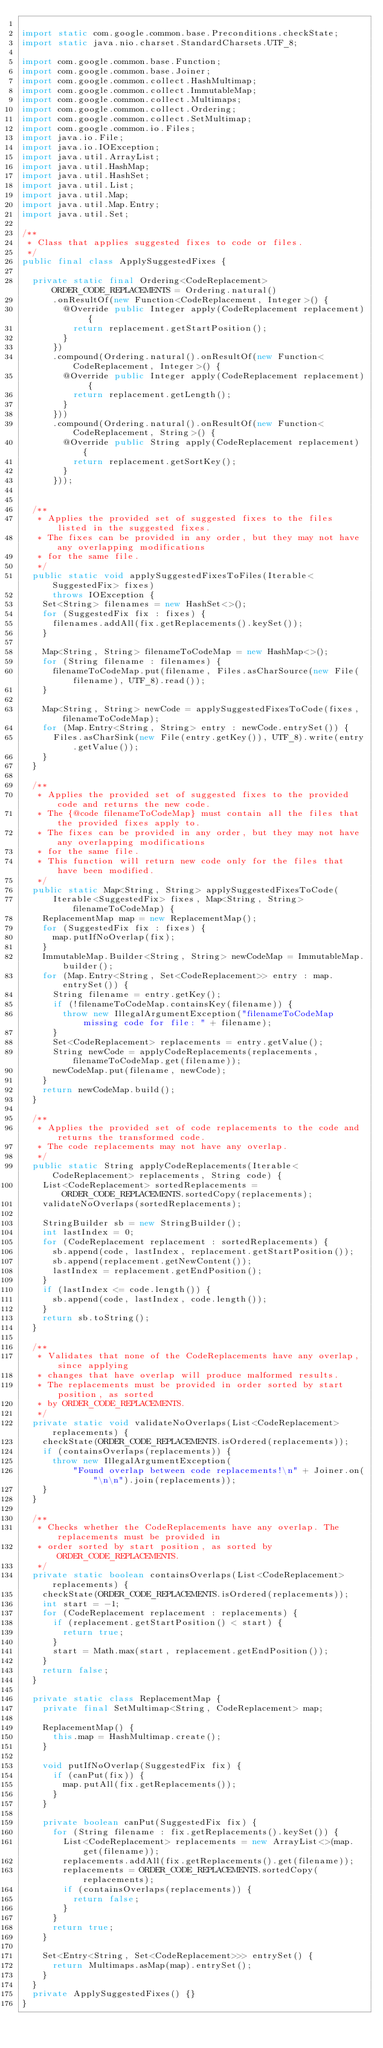<code> <loc_0><loc_0><loc_500><loc_500><_Java_>
import static com.google.common.base.Preconditions.checkState;
import static java.nio.charset.StandardCharsets.UTF_8;

import com.google.common.base.Function;
import com.google.common.base.Joiner;
import com.google.common.collect.HashMultimap;
import com.google.common.collect.ImmutableMap;
import com.google.common.collect.Multimaps;
import com.google.common.collect.Ordering;
import com.google.common.collect.SetMultimap;
import com.google.common.io.Files;
import java.io.File;
import java.io.IOException;
import java.util.ArrayList;
import java.util.HashMap;
import java.util.HashSet;
import java.util.List;
import java.util.Map;
import java.util.Map.Entry;
import java.util.Set;

/**
 * Class that applies suggested fixes to code or files.
 */
public final class ApplySuggestedFixes {

  private static final Ordering<CodeReplacement> ORDER_CODE_REPLACEMENTS = Ordering.natural()
      .onResultOf(new Function<CodeReplacement, Integer>() {
        @Override public Integer apply(CodeReplacement replacement) {
          return replacement.getStartPosition();
        }
      })
      .compound(Ordering.natural().onResultOf(new Function<CodeReplacement, Integer>() {
        @Override public Integer apply(CodeReplacement replacement) {
          return replacement.getLength();
        }
      }))
      .compound(Ordering.natural().onResultOf(new Function<CodeReplacement, String>() {
        @Override public String apply(CodeReplacement replacement) {
          return replacement.getSortKey();
        }
      }));


  /**
   * Applies the provided set of suggested fixes to the files listed in the suggested fixes.
   * The fixes can be provided in any order, but they may not have any overlapping modifications
   * for the same file.
   */
  public static void applySuggestedFixesToFiles(Iterable<SuggestedFix> fixes)
      throws IOException {
    Set<String> filenames = new HashSet<>();
    for (SuggestedFix fix : fixes) {
      filenames.addAll(fix.getReplacements().keySet());
    }

    Map<String, String> filenameToCodeMap = new HashMap<>();
    for (String filename : filenames) {
      filenameToCodeMap.put(filename, Files.asCharSource(new File(filename), UTF_8).read());
    }

    Map<String, String> newCode = applySuggestedFixesToCode(fixes, filenameToCodeMap);
    for (Map.Entry<String, String> entry : newCode.entrySet()) {
      Files.asCharSink(new File(entry.getKey()), UTF_8).write(entry.getValue());
    }
  }

  /**
   * Applies the provided set of suggested fixes to the provided code and returns the new code.
   * The {@code filenameToCodeMap} must contain all the files that the provided fixes apply to.
   * The fixes can be provided in any order, but they may not have any overlapping modifications
   * for the same file.
   * This function will return new code only for the files that have been modified.
   */
  public static Map<String, String> applySuggestedFixesToCode(
      Iterable<SuggestedFix> fixes, Map<String, String> filenameToCodeMap) {
    ReplacementMap map = new ReplacementMap();
    for (SuggestedFix fix : fixes) {
      map.putIfNoOverlap(fix);
    }
    ImmutableMap.Builder<String, String> newCodeMap = ImmutableMap.builder();
    for (Map.Entry<String, Set<CodeReplacement>> entry : map.entrySet()) {
      String filename = entry.getKey();
      if (!filenameToCodeMap.containsKey(filename)) {
        throw new IllegalArgumentException("filenameToCodeMap missing code for file: " + filename);
      }
      Set<CodeReplacement> replacements = entry.getValue();
      String newCode = applyCodeReplacements(replacements, filenameToCodeMap.get(filename));
      newCodeMap.put(filename, newCode);
    }
    return newCodeMap.build();
  }

  /**
   * Applies the provided set of code replacements to the code and returns the transformed code.
   * The code replacements may not have any overlap.
   */
  public static String applyCodeReplacements(Iterable<CodeReplacement> replacements, String code) {
    List<CodeReplacement> sortedReplacements = ORDER_CODE_REPLACEMENTS.sortedCopy(replacements);
    validateNoOverlaps(sortedReplacements);

    StringBuilder sb = new StringBuilder();
    int lastIndex = 0;
    for (CodeReplacement replacement : sortedReplacements) {
      sb.append(code, lastIndex, replacement.getStartPosition());
      sb.append(replacement.getNewContent());
      lastIndex = replacement.getEndPosition();
    }
    if (lastIndex <= code.length()) {
      sb.append(code, lastIndex, code.length());
    }
    return sb.toString();
  }

  /**
   * Validates that none of the CodeReplacements have any overlap, since applying
   * changes that have overlap will produce malformed results.
   * The replacements must be provided in order sorted by start position, as sorted
   * by ORDER_CODE_REPLACEMENTS.
   */
  private static void validateNoOverlaps(List<CodeReplacement> replacements) {
    checkState(ORDER_CODE_REPLACEMENTS.isOrdered(replacements));
    if (containsOverlaps(replacements)) {
      throw new IllegalArgumentException(
          "Found overlap between code replacements!\n" + Joiner.on("\n\n").join(replacements));
    }
  }

  /**
   * Checks whether the CodeReplacements have any overlap. The replacements must be provided in
   * order sorted by start position, as sorted by ORDER_CODE_REPLACEMENTS.
   */
  private static boolean containsOverlaps(List<CodeReplacement> replacements) {
    checkState(ORDER_CODE_REPLACEMENTS.isOrdered(replacements));
    int start = -1;
    for (CodeReplacement replacement : replacements) {
      if (replacement.getStartPosition() < start) {
        return true;
      }
      start = Math.max(start, replacement.getEndPosition());
    }
    return false;
  }

  private static class ReplacementMap {
    private final SetMultimap<String, CodeReplacement> map;

    ReplacementMap() {
      this.map = HashMultimap.create();
    }

    void putIfNoOverlap(SuggestedFix fix) {
      if (canPut(fix)) {
        map.putAll(fix.getReplacements());
      }
    }

    private boolean canPut(SuggestedFix fix) {
      for (String filename : fix.getReplacements().keySet()) {
        List<CodeReplacement> replacements = new ArrayList<>(map.get(filename));
        replacements.addAll(fix.getReplacements().get(filename));
        replacements = ORDER_CODE_REPLACEMENTS.sortedCopy(replacements);
        if (containsOverlaps(replacements)) {
          return false;
        }
      }
      return true;
    }

    Set<Entry<String, Set<CodeReplacement>>> entrySet() {
      return Multimaps.asMap(map).entrySet();
    }
  }
  private ApplySuggestedFixes() {}
}
</code> 